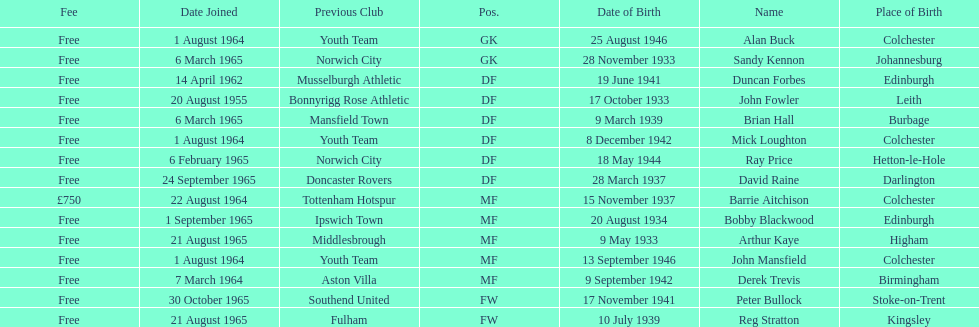Would you mind parsing the complete table? {'header': ['Fee', 'Date Joined', 'Previous Club', 'Pos.', 'Date of Birth', 'Name', 'Place of Birth'], 'rows': [['Free', '1 August 1964', 'Youth Team', 'GK', '25 August 1946', 'Alan Buck', 'Colchester'], ['Free', '6 March 1965', 'Norwich City', 'GK', '28 November 1933', 'Sandy Kennon', 'Johannesburg'], ['Free', '14 April 1962', 'Musselburgh Athletic', 'DF', '19 June 1941', 'Duncan Forbes', 'Edinburgh'], ['Free', '20 August 1955', 'Bonnyrigg Rose Athletic', 'DF', '17 October 1933', 'John Fowler', 'Leith'], ['Free', '6 March 1965', 'Mansfield Town', 'DF', '9 March 1939', 'Brian Hall', 'Burbage'], ['Free', '1 August 1964', 'Youth Team', 'DF', '8 December 1942', 'Mick Loughton', 'Colchester'], ['Free', '6 February 1965', 'Norwich City', 'DF', '18 May 1944', 'Ray Price', 'Hetton-le-Hole'], ['Free', '24 September 1965', 'Doncaster Rovers', 'DF', '28 March 1937', 'David Raine', 'Darlington'], ['£750', '22 August 1964', 'Tottenham Hotspur', 'MF', '15 November 1937', 'Barrie Aitchison', 'Colchester'], ['Free', '1 September 1965', 'Ipswich Town', 'MF', '20 August 1934', 'Bobby Blackwood', 'Edinburgh'], ['Free', '21 August 1965', 'Middlesbrough', 'MF', '9 May 1933', 'Arthur Kaye', 'Higham'], ['Free', '1 August 1964', 'Youth Team', 'MF', '13 September 1946', 'John Mansfield', 'Colchester'], ['Free', '7 March 1964', 'Aston Villa', 'MF', '9 September 1942', 'Derek Trevis', 'Birmingham'], ['Free', '30 October 1965', 'Southend United', 'FW', '17 November 1941', 'Peter Bullock', 'Stoke-on-Trent'], ['Free', '21 August 1965', 'Fulham', 'FW', '10 July 1939', 'Reg Stratton', 'Kingsley']]} On which date did the first player join? 20 August 1955. 